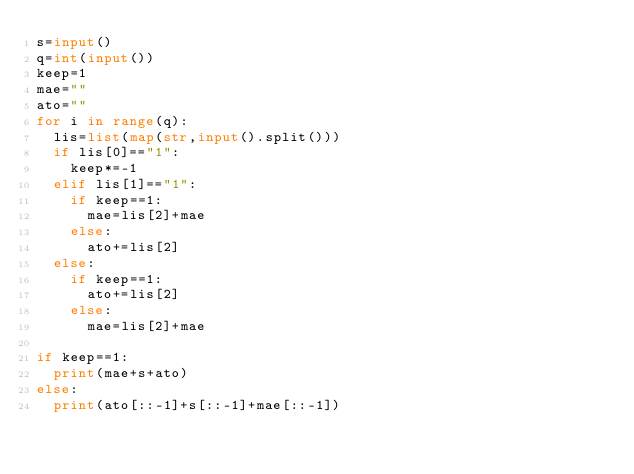Convert code to text. <code><loc_0><loc_0><loc_500><loc_500><_Python_>s=input()
q=int(input())
keep=1
mae=""
ato=""
for i in range(q):
  lis=list(map(str,input().split()))
  if lis[0]=="1":
    keep*=-1
  elif lis[1]=="1":
    if keep==1:
      mae=lis[2]+mae
    else:
      ato+=lis[2]
  else:
    if keep==1:
      ato+=lis[2]
    else:
      mae=lis[2]+mae

if keep==1:
  print(mae+s+ato)
else:
  print(ato[::-1]+s[::-1]+mae[::-1])
  </code> 